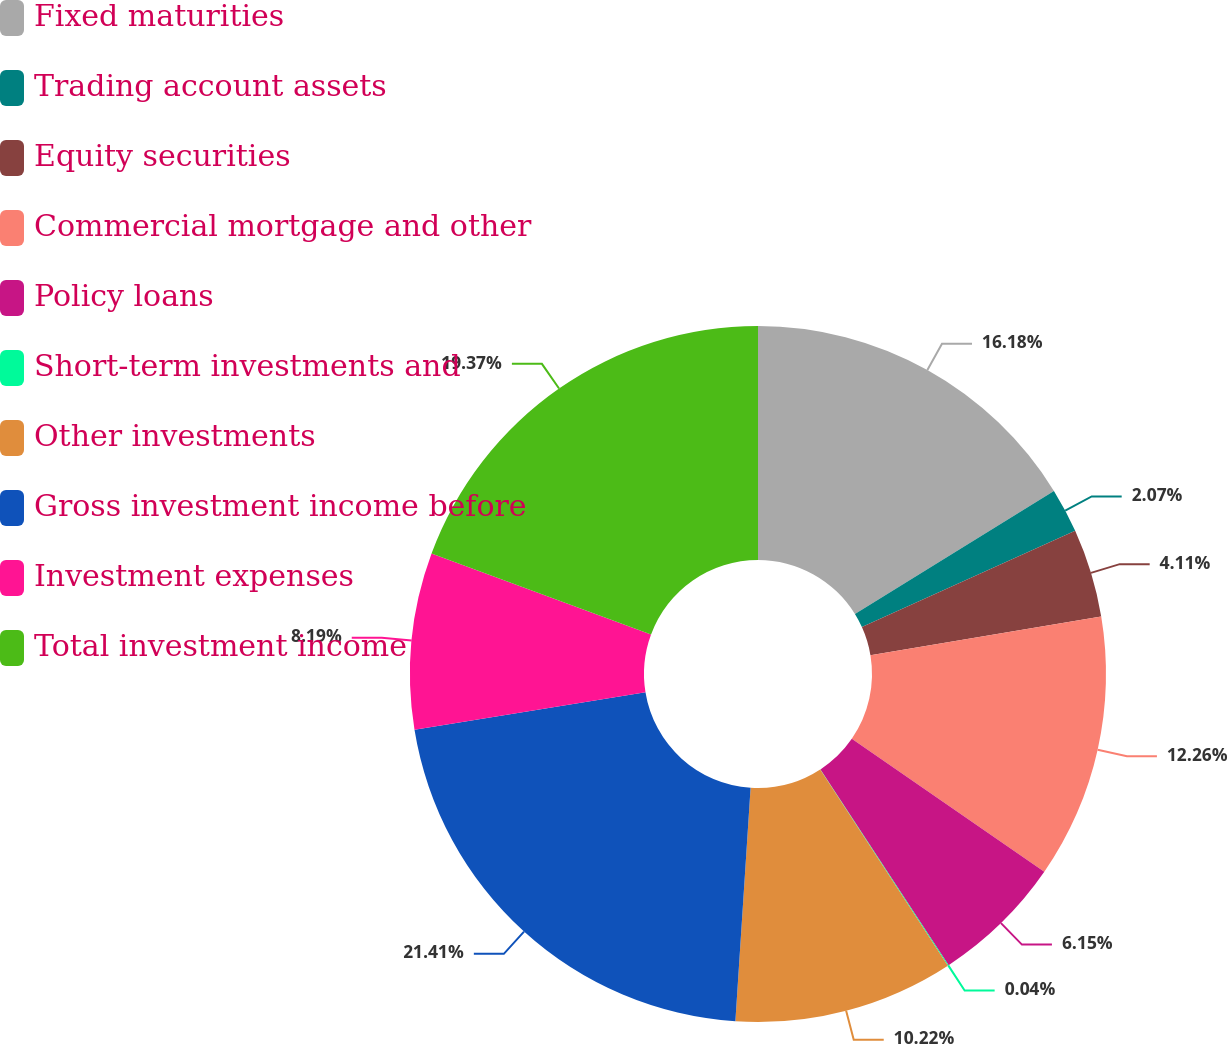<chart> <loc_0><loc_0><loc_500><loc_500><pie_chart><fcel>Fixed maturities<fcel>Trading account assets<fcel>Equity securities<fcel>Commercial mortgage and other<fcel>Policy loans<fcel>Short-term investments and<fcel>Other investments<fcel>Gross investment income before<fcel>Investment expenses<fcel>Total investment income<nl><fcel>16.18%<fcel>2.07%<fcel>4.11%<fcel>12.26%<fcel>6.15%<fcel>0.04%<fcel>10.22%<fcel>21.4%<fcel>8.19%<fcel>19.37%<nl></chart> 